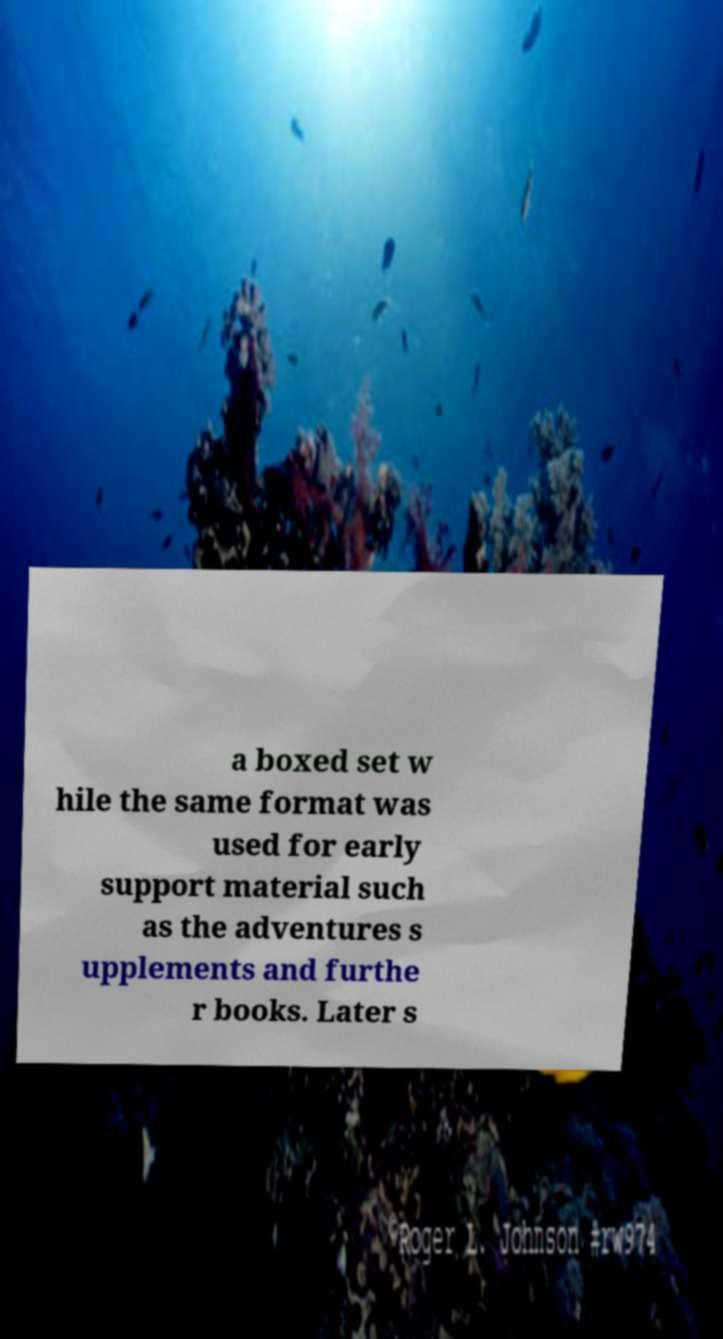I need the written content from this picture converted into text. Can you do that? a boxed set w hile the same format was used for early support material such as the adventures s upplements and furthe r books. Later s 